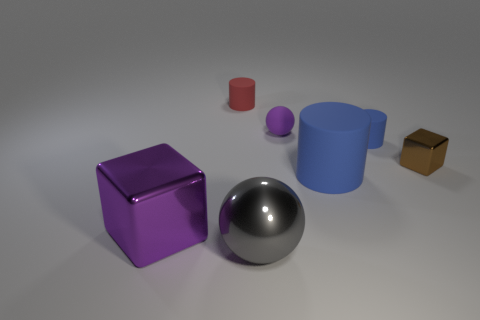How many balls are there?
Give a very brief answer. 2. How many things are in front of the tiny blue thing and to the left of the big cylinder?
Provide a short and direct response. 2. Are there any other things that have the same shape as the small blue rubber object?
Your answer should be compact. Yes. Does the big matte object have the same color as the big shiny object behind the gray object?
Your answer should be very brief. No. The big shiny thing that is left of the tiny red cylinder has what shape?
Provide a succinct answer. Cube. What number of other objects are there of the same material as the big blue thing?
Your answer should be very brief. 3. What material is the small red thing?
Offer a terse response. Rubber. How many tiny things are things or purple metal objects?
Your answer should be very brief. 4. There is a small brown shiny thing; what number of tiny matte cylinders are to the right of it?
Make the answer very short. 0. Are there any small rubber cylinders of the same color as the tiny metal object?
Your answer should be very brief. No. 